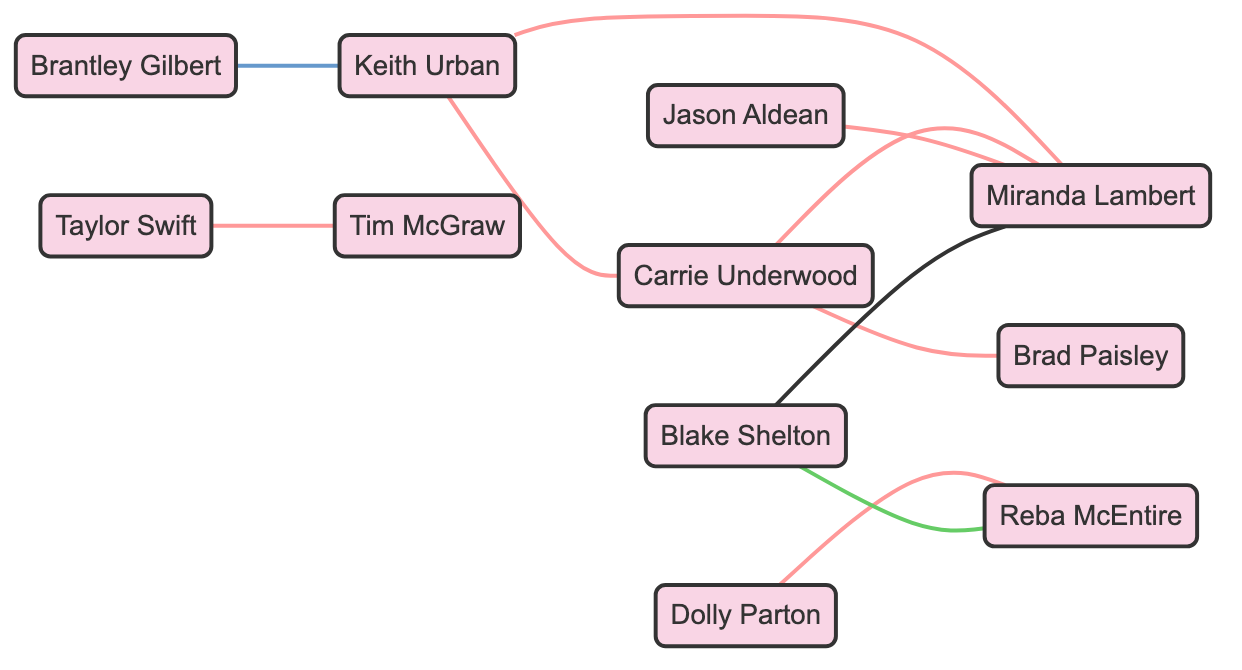What is the total number of nodes in the diagram? The diagram includes 10 unique country music artists specified in the nodes section. Therefore, counting each artist gives us a total of 10 nodes.
Answer: 10 Which artist has collaborated with both Carrie Underwood and Miranda Lambert? By examining the edges, Carrie Underwood is connected to Miranda Lambert through a collaboration, confirming she has collaborated with both.
Answer: Carrie Underwood How many artists has Blake Shelton collaborated with? The edges show Blake Shelton is connected to two artists: Reba McEntire and Miranda Lambert, indicating two collaborations.
Answer: 2 What specific type of relationship exists between Brantley Gilbert and Keith Urban? The edge between Brantley Gilbert and Keith Urban is labeled "opened_for," indicating that Brantley Gilbert opened for Keith Urban, which is a specific type of connection.
Answer: opened_for Which two artists are connected through a mentoring relationship? The diagram indicates a mentoring relationship from Blake Shelton to Reba McEntire based on the label attached to their edge.
Answer: Blake Shelton and Reba McEntire What is the total number of collaborations represented in the diagram? Counting all the edges labeled as "collaborated," there are 6 such edges, indicating a total of 6 collaborations.
Answer: 6 Which artist collaborated with Jason Aldean? From the edges, Jason Aldean is specifically connected to Miranda Lambert through a collaboration.
Answer: Miranda Lambert Which artist has worked with both Keith Urban and Miranda Lambert? The edges indicate that Keith Urban and Miranda Lambert are both connected to Carrie Underwood, making her the artist who collaborated with both.
Answer: Carrie Underwood Are there any artists connected through both collaboration and mentorship? Blake Shelton is connected to Reba McEntire through mentorship and to Miranda Lambert through collaboration, showing that he is involved in both types of relationships.
Answer: Yes 